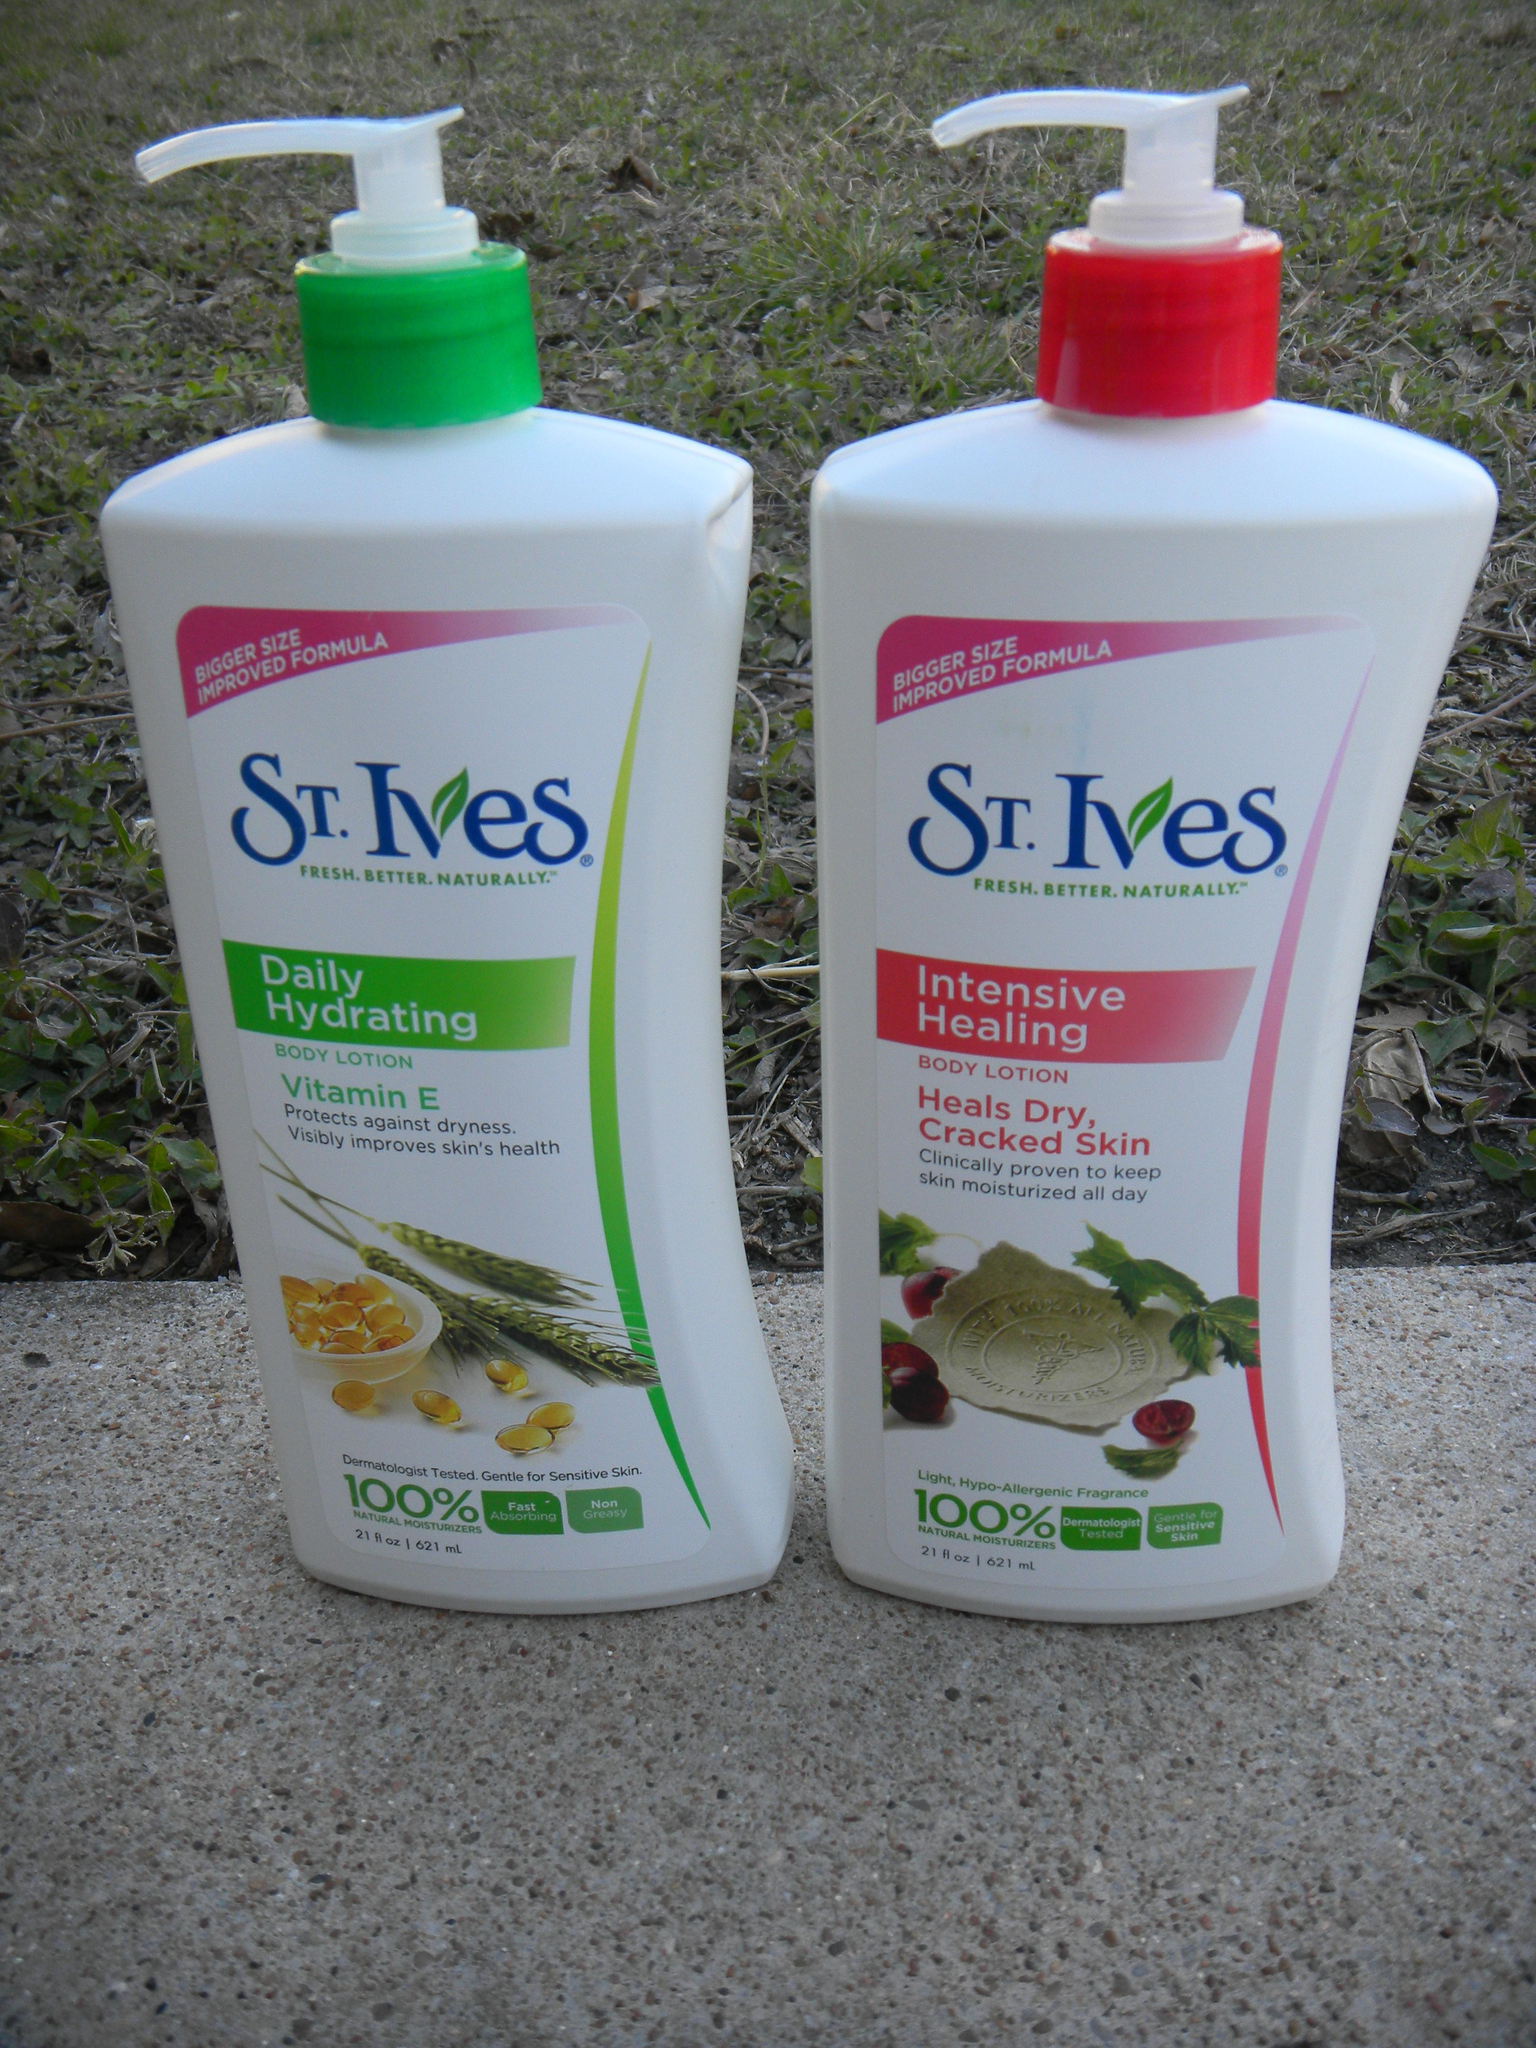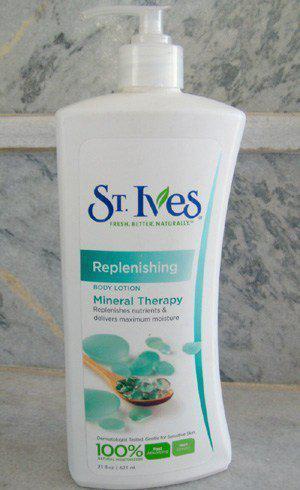The first image is the image on the left, the second image is the image on the right. Examine the images to the left and right. Is the description "One image shows exactly one pump-top product with the nozzle facing right, and the other image shows exactly one pump-top product with the nozzle facing left." accurate? Answer yes or no. No. The first image is the image on the left, the second image is the image on the right. Given the left and right images, does the statement "Each image has one bottle of lotion with a pump top, both the same brand, but with different labels." hold true? Answer yes or no. No. 